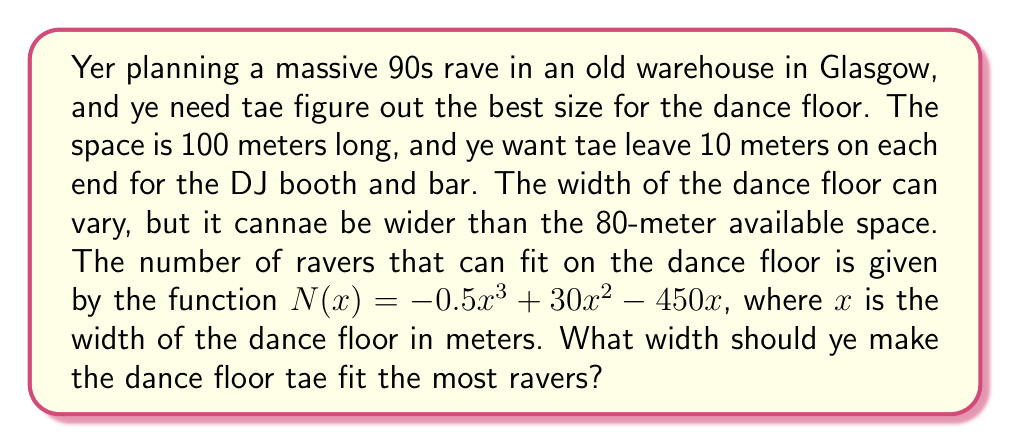Could you help me with this problem? Awright, let's break this down step by step:

1) We've got a cubic function for the number of ravers:
   $N(x) = -0.5x^3 + 30x^2 - 450x$

2) To find the maximum number of ravers, we need tae find the maximum of this function. The maximum occurs where the derivative equals zero.

3) Let's find the derivative:
   $N'(x) = -1.5x^2 + 60x - 450$

4) Set the derivative equal tae zero:
   $-1.5x^2 + 60x - 450 = 0$

5) This is a quadratic equation. We can solve it using the quadratic formula:
   $x = \frac{-b \pm \sqrt{b^2 - 4ac}}{2a}$

   Where $a = -1.5$, $b = 60$, and $c = -450$

6) Plugging in these values:
   $x = \frac{-60 \pm \sqrt{60^2 - 4(-1.5)(-450)}}{2(-1.5)}$

7) Simplifying:
   $x = \frac{-60 \pm \sqrt{3600 - 2700}}{-3} = \frac{-60 \pm \sqrt{900}}{-3} = \frac{-60 \pm 30}{-3}$

8) This gives us two solutions:
   $x_1 = \frac{-60 + 30}{-3} = 10$ and $x_2 = \frac{-60 - 30}{-3} = 30$

9) The second solution, $x = 30$, is within our constraint of 0 to 80 meters, so this is our answer.

10) To confirm this is a maximum (not a minimum), we can check the second derivative:
    $N''(x) = -3x + 60$
    At $x = 30$, $N''(30) = -30 < 0$, confirming this is indeed a maximum.

Therefore, the optimal width for the dance floor is 30 meters.
Answer: The optimal width for the dance floor is 30 meters. 